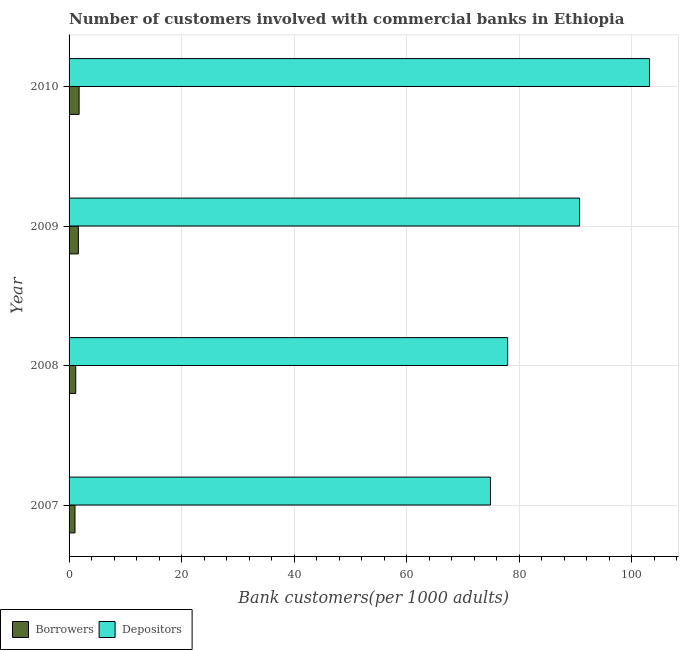How many groups of bars are there?
Offer a terse response. 4. Are the number of bars per tick equal to the number of legend labels?
Make the answer very short. Yes. How many bars are there on the 4th tick from the top?
Offer a very short reply. 2. How many bars are there on the 2nd tick from the bottom?
Offer a terse response. 2. What is the label of the 4th group of bars from the top?
Provide a short and direct response. 2007. In how many cases, is the number of bars for a given year not equal to the number of legend labels?
Offer a very short reply. 0. What is the number of depositors in 2010?
Offer a very short reply. 103.16. Across all years, what is the maximum number of depositors?
Offer a very short reply. 103.16. Across all years, what is the minimum number of borrowers?
Keep it short and to the point. 1.05. In which year was the number of borrowers minimum?
Give a very brief answer. 2007. What is the total number of borrowers in the graph?
Your response must be concise. 5.67. What is the difference between the number of depositors in 2007 and that in 2008?
Your answer should be very brief. -3.06. What is the difference between the number of borrowers in 2010 and the number of depositors in 2008?
Your answer should be compact. -76.17. What is the average number of depositors per year?
Provide a short and direct response. 86.69. In the year 2009, what is the difference between the number of borrowers and number of depositors?
Give a very brief answer. -89.09. In how many years, is the number of borrowers greater than 60 ?
Make the answer very short. 0. What is the ratio of the number of borrowers in 2007 to that in 2009?
Your answer should be compact. 0.64. Is the number of depositors in 2007 less than that in 2010?
Offer a terse response. Yes. Is the difference between the number of borrowers in 2009 and 2010 greater than the difference between the number of depositors in 2009 and 2010?
Your answer should be compact. Yes. What is the difference between the highest and the second highest number of borrowers?
Your response must be concise. 0.13. What is the difference between the highest and the lowest number of depositors?
Your answer should be very brief. 28.26. In how many years, is the number of borrowers greater than the average number of borrowers taken over all years?
Keep it short and to the point. 2. What does the 1st bar from the top in 2007 represents?
Your answer should be compact. Depositors. What does the 1st bar from the bottom in 2010 represents?
Give a very brief answer. Borrowers. What is the difference between two consecutive major ticks on the X-axis?
Make the answer very short. 20. How many legend labels are there?
Offer a terse response. 2. What is the title of the graph?
Give a very brief answer. Number of customers involved with commercial banks in Ethiopia. Does "Import" appear as one of the legend labels in the graph?
Your answer should be very brief. No. What is the label or title of the X-axis?
Offer a very short reply. Bank customers(per 1000 adults). What is the label or title of the Y-axis?
Give a very brief answer. Year. What is the Bank customers(per 1000 adults) in Borrowers in 2007?
Your answer should be very brief. 1.05. What is the Bank customers(per 1000 adults) in Depositors in 2007?
Your answer should be very brief. 74.89. What is the Bank customers(per 1000 adults) in Borrowers in 2008?
Keep it short and to the point. 1.18. What is the Bank customers(per 1000 adults) in Depositors in 2008?
Offer a very short reply. 77.95. What is the Bank customers(per 1000 adults) in Borrowers in 2009?
Your answer should be very brief. 1.65. What is the Bank customers(per 1000 adults) of Depositors in 2009?
Provide a short and direct response. 90.74. What is the Bank customers(per 1000 adults) in Borrowers in 2010?
Your response must be concise. 1.78. What is the Bank customers(per 1000 adults) of Depositors in 2010?
Make the answer very short. 103.16. Across all years, what is the maximum Bank customers(per 1000 adults) in Borrowers?
Your answer should be compact. 1.78. Across all years, what is the maximum Bank customers(per 1000 adults) of Depositors?
Your answer should be compact. 103.16. Across all years, what is the minimum Bank customers(per 1000 adults) in Borrowers?
Offer a terse response. 1.05. Across all years, what is the minimum Bank customers(per 1000 adults) in Depositors?
Offer a terse response. 74.89. What is the total Bank customers(per 1000 adults) of Borrowers in the graph?
Ensure brevity in your answer.  5.67. What is the total Bank customers(per 1000 adults) of Depositors in the graph?
Your response must be concise. 346.74. What is the difference between the Bank customers(per 1000 adults) of Borrowers in 2007 and that in 2008?
Ensure brevity in your answer.  -0.13. What is the difference between the Bank customers(per 1000 adults) of Depositors in 2007 and that in 2008?
Provide a succinct answer. -3.06. What is the difference between the Bank customers(per 1000 adults) in Borrowers in 2007 and that in 2009?
Offer a terse response. -0.6. What is the difference between the Bank customers(per 1000 adults) of Depositors in 2007 and that in 2009?
Offer a very short reply. -15.85. What is the difference between the Bank customers(per 1000 adults) in Borrowers in 2007 and that in 2010?
Provide a succinct answer. -0.73. What is the difference between the Bank customers(per 1000 adults) in Depositors in 2007 and that in 2010?
Your answer should be very brief. -28.26. What is the difference between the Bank customers(per 1000 adults) in Borrowers in 2008 and that in 2009?
Your response must be concise. -0.47. What is the difference between the Bank customers(per 1000 adults) of Depositors in 2008 and that in 2009?
Your answer should be very brief. -12.79. What is the difference between the Bank customers(per 1000 adults) of Borrowers in 2008 and that in 2010?
Keep it short and to the point. -0.6. What is the difference between the Bank customers(per 1000 adults) in Depositors in 2008 and that in 2010?
Give a very brief answer. -25.21. What is the difference between the Bank customers(per 1000 adults) of Borrowers in 2009 and that in 2010?
Provide a short and direct response. -0.13. What is the difference between the Bank customers(per 1000 adults) of Depositors in 2009 and that in 2010?
Make the answer very short. -12.42. What is the difference between the Bank customers(per 1000 adults) of Borrowers in 2007 and the Bank customers(per 1000 adults) of Depositors in 2008?
Offer a very short reply. -76.9. What is the difference between the Bank customers(per 1000 adults) of Borrowers in 2007 and the Bank customers(per 1000 adults) of Depositors in 2009?
Provide a succinct answer. -89.69. What is the difference between the Bank customers(per 1000 adults) of Borrowers in 2007 and the Bank customers(per 1000 adults) of Depositors in 2010?
Offer a terse response. -102.1. What is the difference between the Bank customers(per 1000 adults) of Borrowers in 2008 and the Bank customers(per 1000 adults) of Depositors in 2009?
Offer a very short reply. -89.56. What is the difference between the Bank customers(per 1000 adults) of Borrowers in 2008 and the Bank customers(per 1000 adults) of Depositors in 2010?
Ensure brevity in your answer.  -101.97. What is the difference between the Bank customers(per 1000 adults) in Borrowers in 2009 and the Bank customers(per 1000 adults) in Depositors in 2010?
Provide a short and direct response. -101.51. What is the average Bank customers(per 1000 adults) in Borrowers per year?
Your answer should be very brief. 1.42. What is the average Bank customers(per 1000 adults) of Depositors per year?
Your answer should be compact. 86.69. In the year 2007, what is the difference between the Bank customers(per 1000 adults) of Borrowers and Bank customers(per 1000 adults) of Depositors?
Give a very brief answer. -73.84. In the year 2008, what is the difference between the Bank customers(per 1000 adults) in Borrowers and Bank customers(per 1000 adults) in Depositors?
Make the answer very short. -76.77. In the year 2009, what is the difference between the Bank customers(per 1000 adults) of Borrowers and Bank customers(per 1000 adults) of Depositors?
Your response must be concise. -89.09. In the year 2010, what is the difference between the Bank customers(per 1000 adults) of Borrowers and Bank customers(per 1000 adults) of Depositors?
Provide a short and direct response. -101.37. What is the ratio of the Bank customers(per 1000 adults) of Borrowers in 2007 to that in 2008?
Provide a succinct answer. 0.89. What is the ratio of the Bank customers(per 1000 adults) of Depositors in 2007 to that in 2008?
Provide a succinct answer. 0.96. What is the ratio of the Bank customers(per 1000 adults) in Borrowers in 2007 to that in 2009?
Your answer should be compact. 0.64. What is the ratio of the Bank customers(per 1000 adults) of Depositors in 2007 to that in 2009?
Provide a short and direct response. 0.83. What is the ratio of the Bank customers(per 1000 adults) of Borrowers in 2007 to that in 2010?
Your response must be concise. 0.59. What is the ratio of the Bank customers(per 1000 adults) in Depositors in 2007 to that in 2010?
Ensure brevity in your answer.  0.73. What is the ratio of the Bank customers(per 1000 adults) in Borrowers in 2008 to that in 2009?
Your answer should be compact. 0.72. What is the ratio of the Bank customers(per 1000 adults) in Depositors in 2008 to that in 2009?
Your answer should be very brief. 0.86. What is the ratio of the Bank customers(per 1000 adults) in Borrowers in 2008 to that in 2010?
Ensure brevity in your answer.  0.66. What is the ratio of the Bank customers(per 1000 adults) of Depositors in 2008 to that in 2010?
Offer a terse response. 0.76. What is the ratio of the Bank customers(per 1000 adults) in Borrowers in 2009 to that in 2010?
Offer a terse response. 0.93. What is the ratio of the Bank customers(per 1000 adults) in Depositors in 2009 to that in 2010?
Your answer should be very brief. 0.88. What is the difference between the highest and the second highest Bank customers(per 1000 adults) of Borrowers?
Your answer should be very brief. 0.13. What is the difference between the highest and the second highest Bank customers(per 1000 adults) in Depositors?
Your answer should be very brief. 12.42. What is the difference between the highest and the lowest Bank customers(per 1000 adults) in Borrowers?
Provide a short and direct response. 0.73. What is the difference between the highest and the lowest Bank customers(per 1000 adults) of Depositors?
Provide a short and direct response. 28.26. 